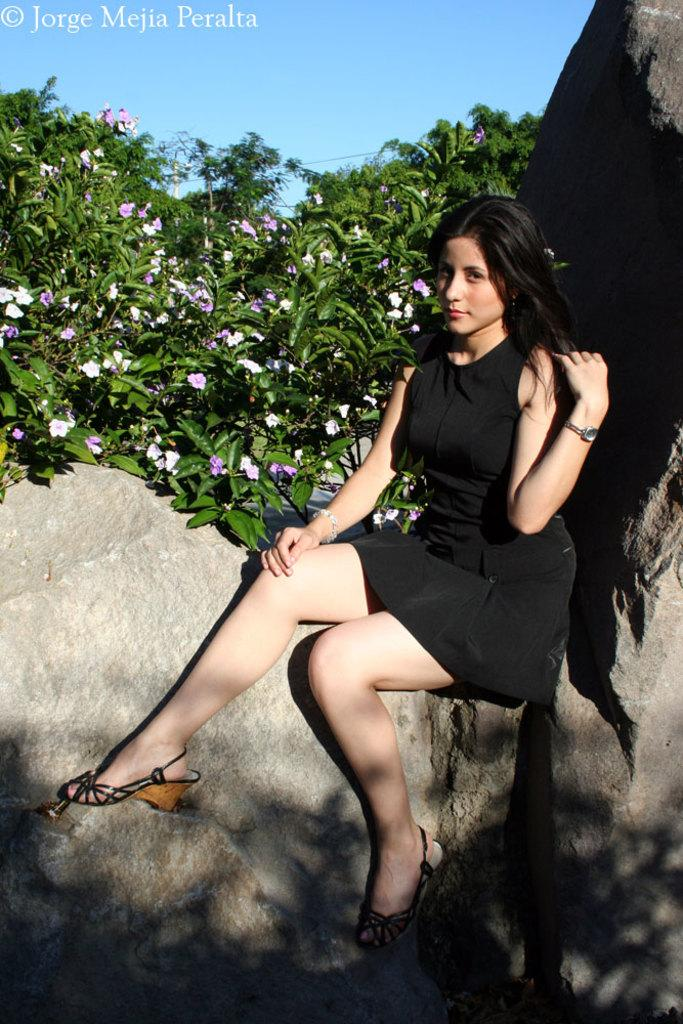Who is the main subject in the image? There is a lady in the image. What is the lady doing in the image? The lady is sitting on a rock. What can be seen in the background of the image? There are trees in the background of the image. What type of meat is the lady cooking in the image? There is no meat or cooking activity present in the image; the lady is sitting on a rock with trees in the background. 